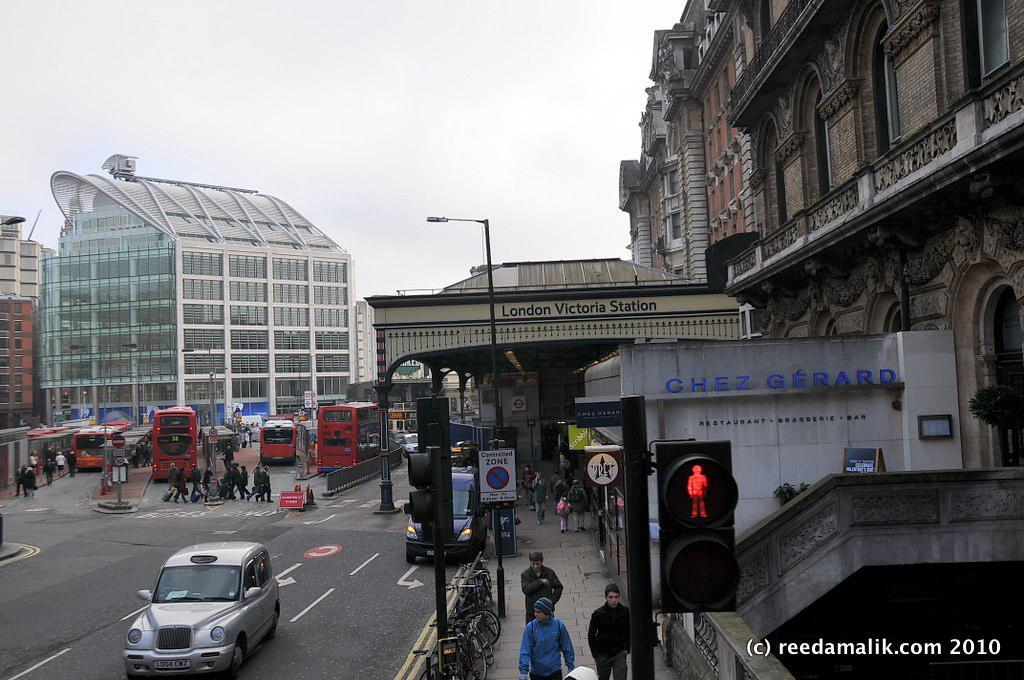<image>
Create a compact narrative representing the image presented. London Victoria Station and a car that is on the road, picture is taken by reedamalik.com 2010/ 